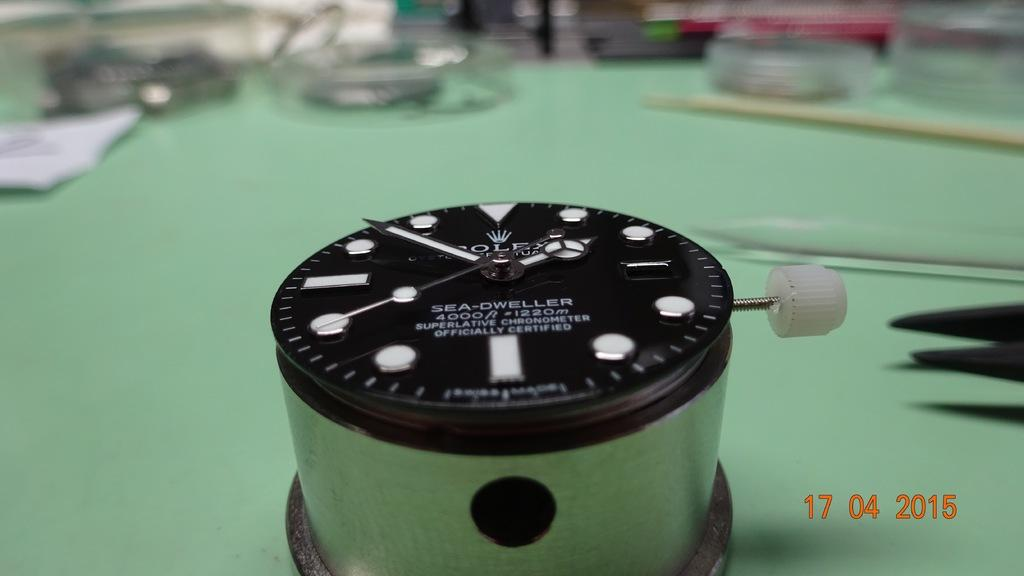<image>
Offer a succinct explanation of the picture presented. A photo that was taken on April 17, 2015 shows a Rolex watch face. 